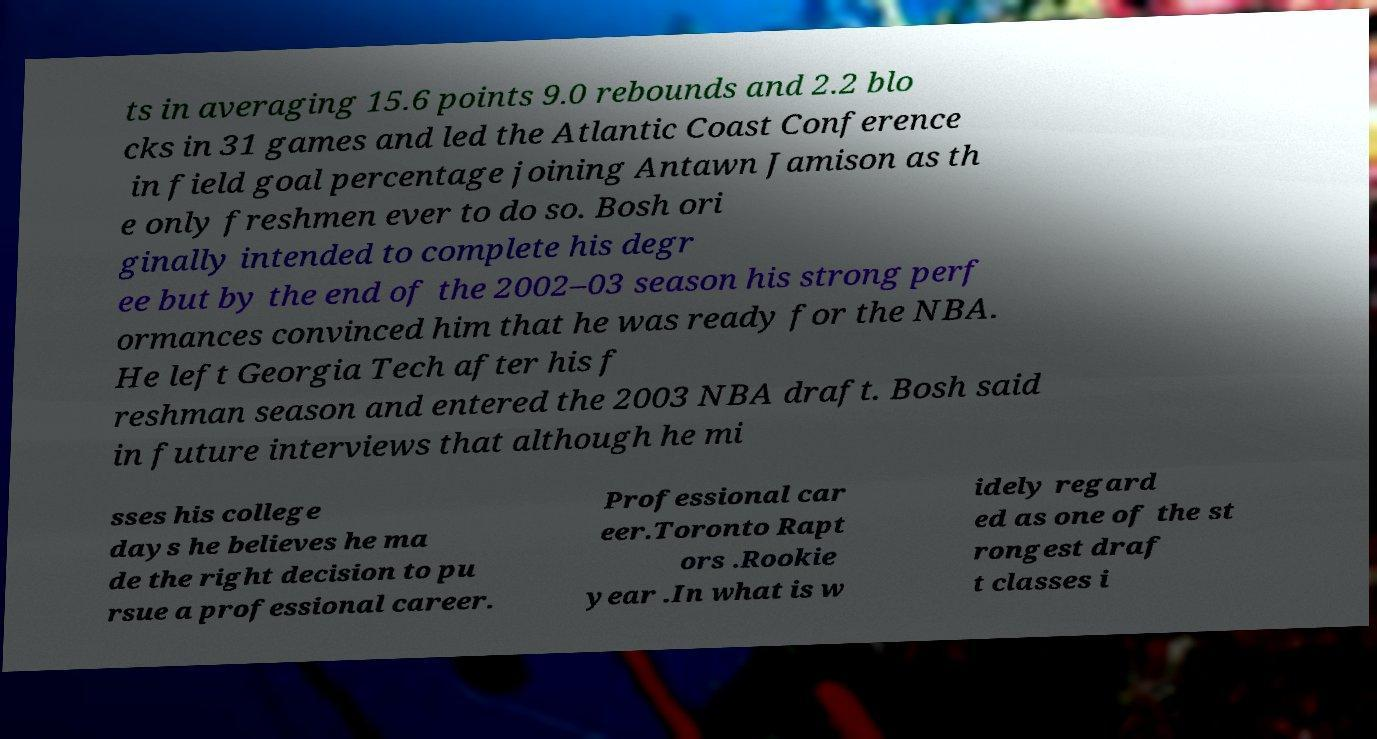What messages or text are displayed in this image? I need them in a readable, typed format. ts in averaging 15.6 points 9.0 rebounds and 2.2 blo cks in 31 games and led the Atlantic Coast Conference in field goal percentage joining Antawn Jamison as th e only freshmen ever to do so. Bosh ori ginally intended to complete his degr ee but by the end of the 2002–03 season his strong perf ormances convinced him that he was ready for the NBA. He left Georgia Tech after his f reshman season and entered the 2003 NBA draft. Bosh said in future interviews that although he mi sses his college days he believes he ma de the right decision to pu rsue a professional career. Professional car eer.Toronto Rapt ors .Rookie year .In what is w idely regard ed as one of the st rongest draf t classes i 